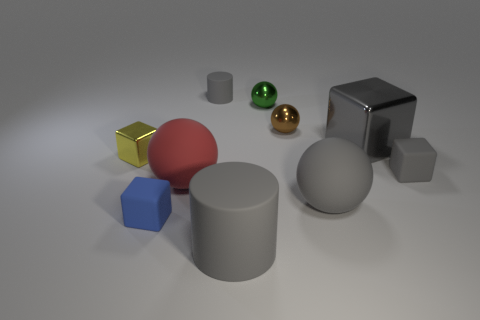There is a small matte block right of the big matte thing on the left side of the tiny matte cylinder; how many small green spheres are in front of it?
Your response must be concise. 0. The matte thing that is both right of the tiny blue rubber cube and in front of the large gray rubber ball is what color?
Offer a very short reply. Gray. What number of other cylinders are the same color as the big rubber cylinder?
Offer a very short reply. 1. How many spheres are tiny yellow things or metallic things?
Make the answer very short. 2. There is a cylinder that is the same size as the green metal ball; what color is it?
Provide a short and direct response. Gray. Are there any brown spheres behind the small green metal thing to the right of the small metallic object in front of the gray shiny thing?
Provide a succinct answer. No. The gray sphere has what size?
Your response must be concise. Large. How many objects are either shiny blocks or green balls?
Make the answer very short. 3. The other big sphere that is made of the same material as the red ball is what color?
Your response must be concise. Gray. There is a tiny metallic thing that is left of the tiny blue block; does it have the same shape as the blue thing?
Provide a succinct answer. Yes. 